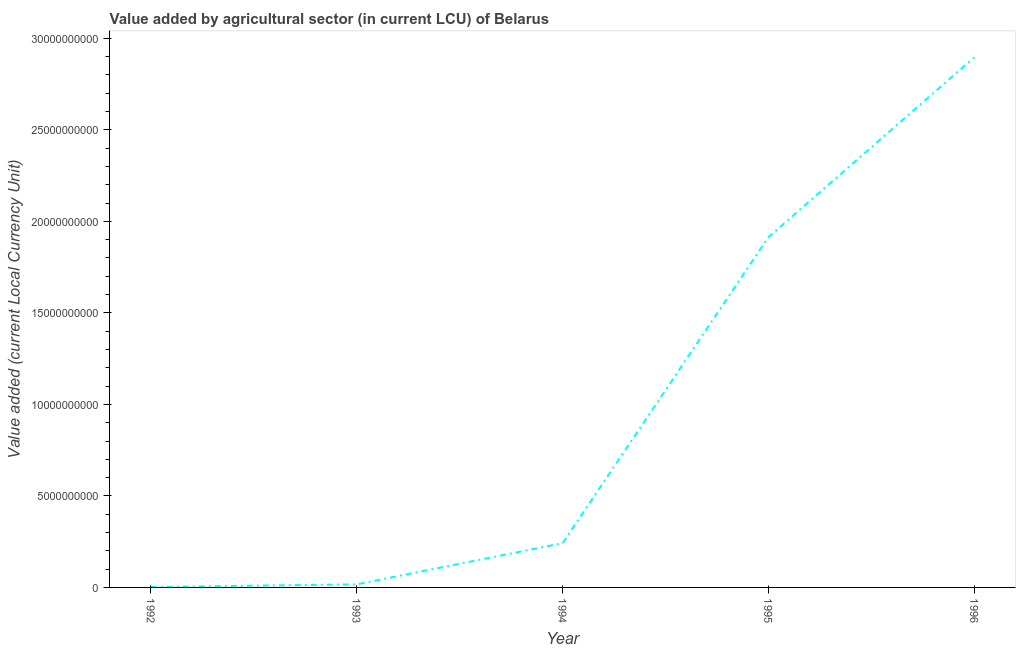What is the value added by agriculture sector in 1992?
Ensure brevity in your answer.  2.07e+07. Across all years, what is the maximum value added by agriculture sector?
Provide a succinct answer. 2.90e+1. Across all years, what is the minimum value added by agriculture sector?
Offer a very short reply. 2.07e+07. In which year was the value added by agriculture sector minimum?
Offer a very short reply. 1992. What is the sum of the value added by agriculture sector?
Provide a succinct answer. 5.07e+1. What is the difference between the value added by agriculture sector in 1994 and 1995?
Provide a succinct answer. -1.67e+1. What is the average value added by agriculture sector per year?
Your answer should be very brief. 1.01e+1. What is the median value added by agriculture sector?
Offer a terse response. 2.42e+09. In how many years, is the value added by agriculture sector greater than 15000000000 LCU?
Your response must be concise. 2. What is the ratio of the value added by agriculture sector in 1992 to that in 1996?
Provide a short and direct response. 0. Is the value added by agriculture sector in 1993 less than that in 1994?
Offer a very short reply. Yes. What is the difference between the highest and the second highest value added by agriculture sector?
Your answer should be compact. 9.82e+09. What is the difference between the highest and the lowest value added by agriculture sector?
Offer a very short reply. 2.89e+1. In how many years, is the value added by agriculture sector greater than the average value added by agriculture sector taken over all years?
Your answer should be very brief. 2. Does the value added by agriculture sector monotonically increase over the years?
Your answer should be very brief. Yes. How many lines are there?
Offer a very short reply. 1. How many years are there in the graph?
Provide a short and direct response. 5. What is the difference between two consecutive major ticks on the Y-axis?
Give a very brief answer. 5.00e+09. Are the values on the major ticks of Y-axis written in scientific E-notation?
Your response must be concise. No. Does the graph contain any zero values?
Provide a succinct answer. No. Does the graph contain grids?
Provide a short and direct response. No. What is the title of the graph?
Provide a short and direct response. Value added by agricultural sector (in current LCU) of Belarus. What is the label or title of the X-axis?
Your answer should be very brief. Year. What is the label or title of the Y-axis?
Keep it short and to the point. Value added (current Local Currency Unit). What is the Value added (current Local Currency Unit) of 1992?
Give a very brief answer. 2.07e+07. What is the Value added (current Local Currency Unit) in 1993?
Offer a terse response. 1.69e+08. What is the Value added (current Local Currency Unit) in 1994?
Your answer should be compact. 2.42e+09. What is the Value added (current Local Currency Unit) of 1995?
Keep it short and to the point. 1.91e+1. What is the Value added (current Local Currency Unit) of 1996?
Ensure brevity in your answer.  2.90e+1. What is the difference between the Value added (current Local Currency Unit) in 1992 and 1993?
Make the answer very short. -1.48e+08. What is the difference between the Value added (current Local Currency Unit) in 1992 and 1994?
Your response must be concise. -2.40e+09. What is the difference between the Value added (current Local Currency Unit) in 1992 and 1995?
Give a very brief answer. -1.91e+1. What is the difference between the Value added (current Local Currency Unit) in 1992 and 1996?
Keep it short and to the point. -2.89e+1. What is the difference between the Value added (current Local Currency Unit) in 1993 and 1994?
Your response must be concise. -2.25e+09. What is the difference between the Value added (current Local Currency Unit) in 1993 and 1995?
Your answer should be very brief. -1.90e+1. What is the difference between the Value added (current Local Currency Unit) in 1993 and 1996?
Ensure brevity in your answer.  -2.88e+1. What is the difference between the Value added (current Local Currency Unit) in 1994 and 1995?
Make the answer very short. -1.67e+1. What is the difference between the Value added (current Local Currency Unit) in 1994 and 1996?
Offer a terse response. -2.65e+1. What is the difference between the Value added (current Local Currency Unit) in 1995 and 1996?
Ensure brevity in your answer.  -9.82e+09. What is the ratio of the Value added (current Local Currency Unit) in 1992 to that in 1993?
Offer a terse response. 0.12. What is the ratio of the Value added (current Local Currency Unit) in 1992 to that in 1994?
Make the answer very short. 0.01. What is the ratio of the Value added (current Local Currency Unit) in 1992 to that in 1995?
Your answer should be compact. 0. What is the ratio of the Value added (current Local Currency Unit) in 1993 to that in 1994?
Your answer should be compact. 0.07. What is the ratio of the Value added (current Local Currency Unit) in 1993 to that in 1995?
Provide a succinct answer. 0.01. What is the ratio of the Value added (current Local Currency Unit) in 1993 to that in 1996?
Your response must be concise. 0.01. What is the ratio of the Value added (current Local Currency Unit) in 1994 to that in 1995?
Provide a short and direct response. 0.13. What is the ratio of the Value added (current Local Currency Unit) in 1994 to that in 1996?
Ensure brevity in your answer.  0.08. What is the ratio of the Value added (current Local Currency Unit) in 1995 to that in 1996?
Ensure brevity in your answer.  0.66. 